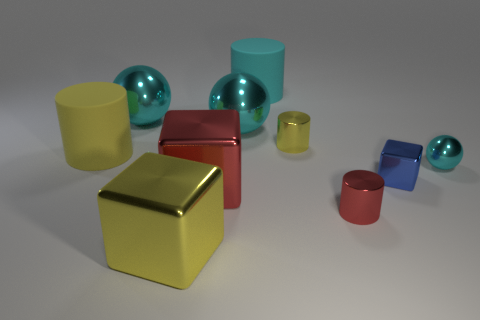Subtract all red cylinders. How many cylinders are left? 3 Subtract all big blocks. How many blocks are left? 1 Subtract all blue balls. How many yellow cylinders are left? 2 Subtract 2 cylinders. How many cylinders are left? 2 Subtract all gray cylinders. Subtract all yellow blocks. How many cylinders are left? 4 Subtract all balls. How many objects are left? 7 Add 1 large yellow rubber balls. How many large yellow rubber balls exist? 1 Subtract 2 yellow cylinders. How many objects are left? 8 Subtract all cyan matte things. Subtract all big red metallic objects. How many objects are left? 8 Add 5 big yellow shiny things. How many big yellow shiny things are left? 6 